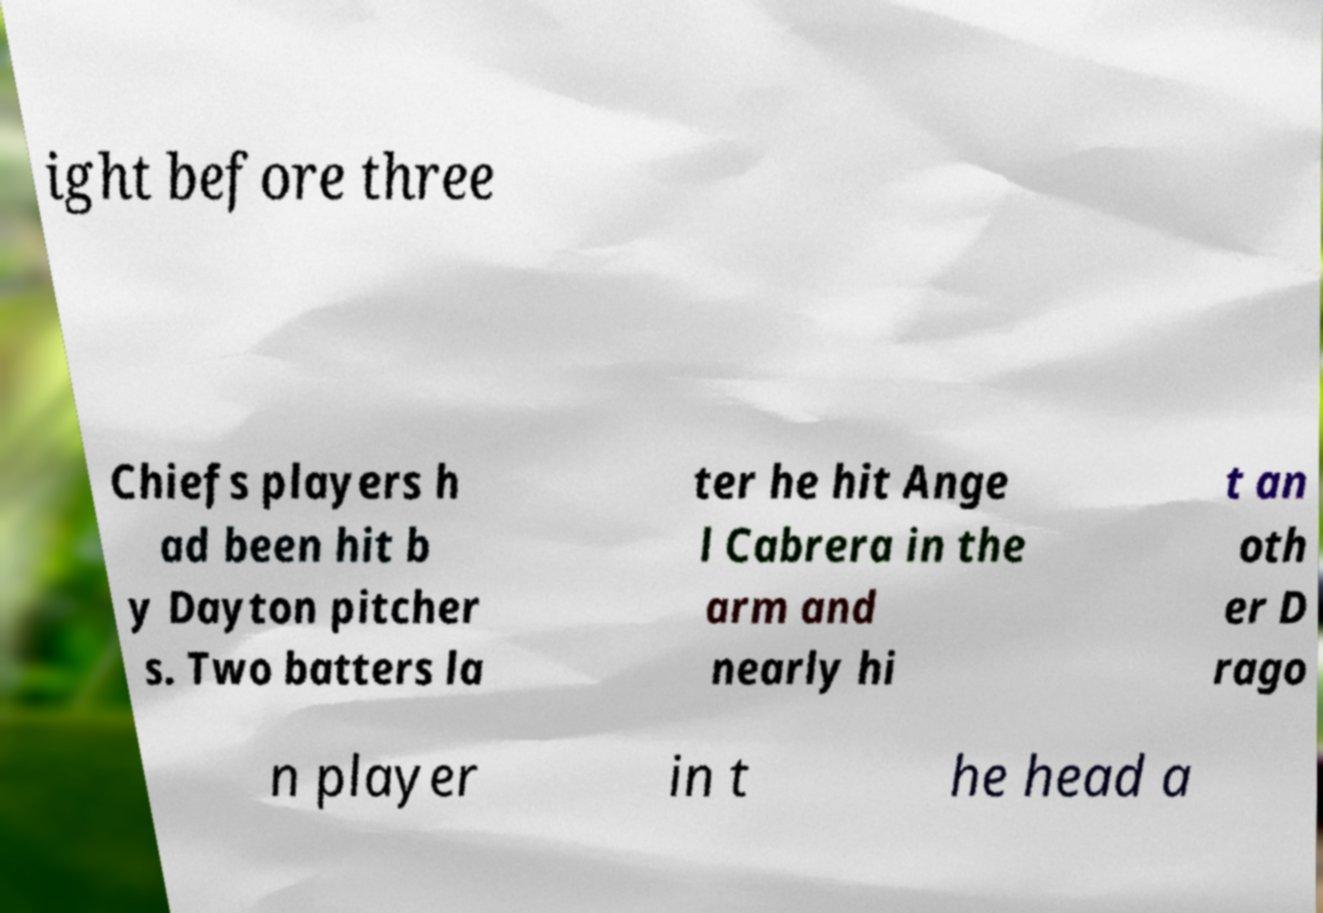What messages or text are displayed in this image? I need them in a readable, typed format. ight before three Chiefs players h ad been hit b y Dayton pitcher s. Two batters la ter he hit Ange l Cabrera in the arm and nearly hi t an oth er D rago n player in t he head a 